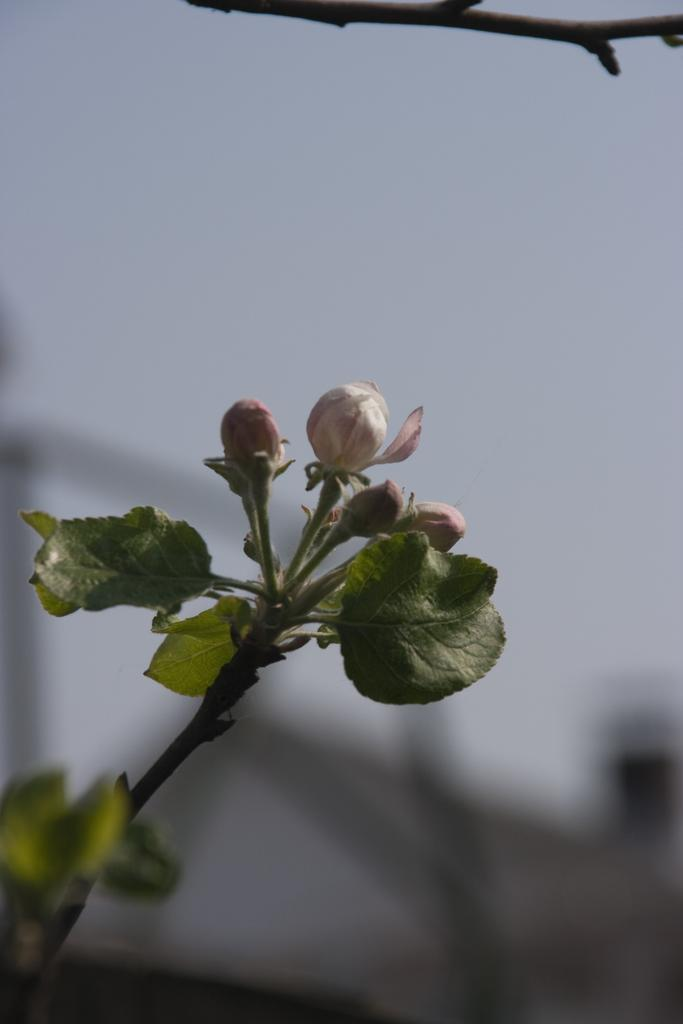What type of plants are in the image? There are small flowers in the image. What color are the leaves of the flowers? The flowers have green leaves. What part of the flowers connects the leaves to the stems? The flowers have green stems. How does the dad feel about the regret in the image? There is no dad or regret present in the image; it only features small flowers with green leaves and stems. 